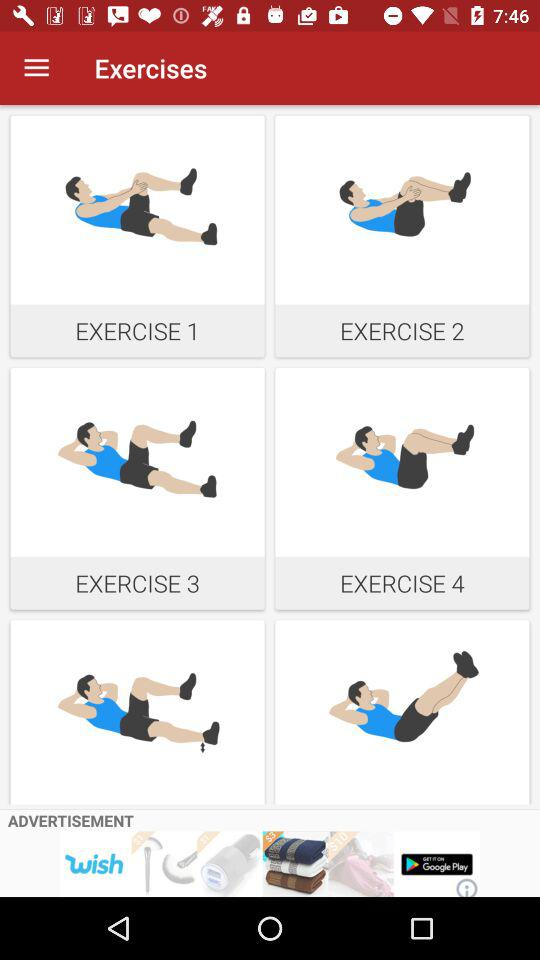How many exercises are there in total?
Answer the question using a single word or phrase. 4 